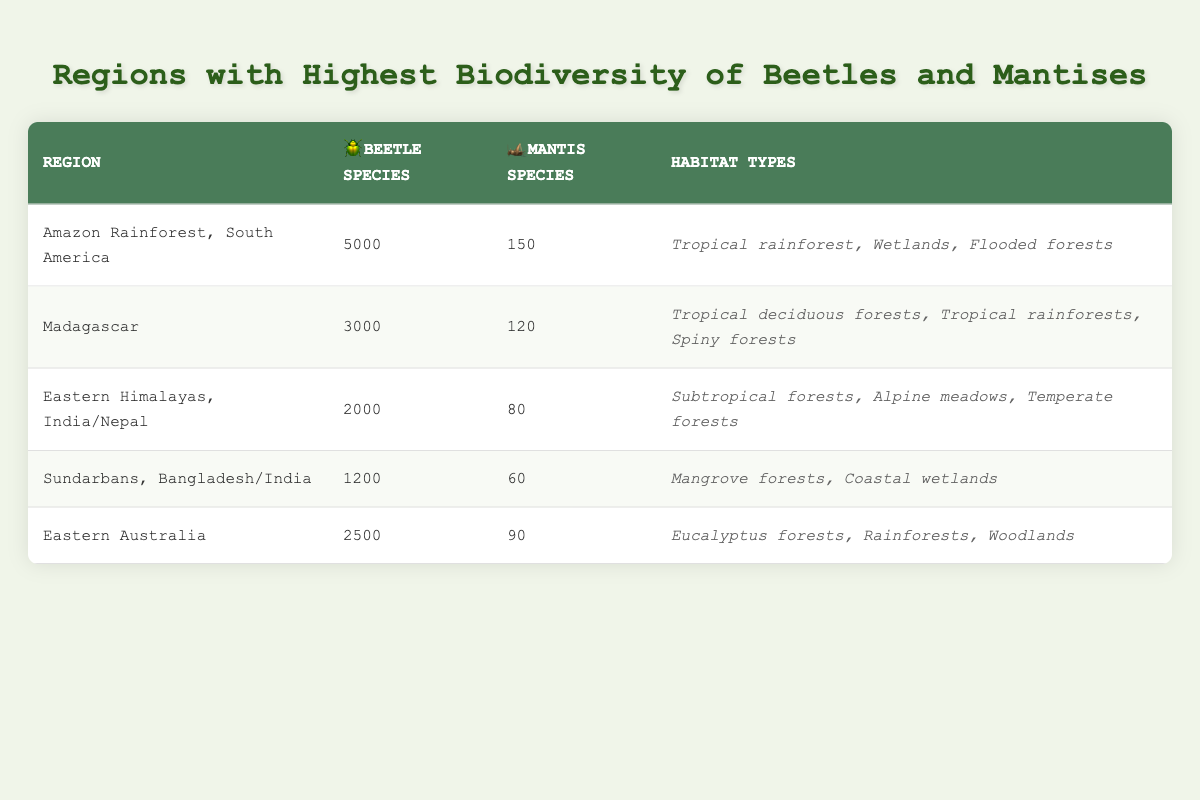What region has the highest count of beetle species? By examining the table, the region with the highest count of beetle species is the Amazon Rainforest, South America, which has 5000 species.
Answer: Amazon Rainforest, South America How many mantis species are found in Madagascar? From the table, Madagascar has 120 species of mantis as indicated in the corresponding column.
Answer: 120 Which region has the lowest number of beetle species? Looking at the beetle species count, Sundarbans has the lowest number with 1200 species.
Answer: Sundarbans, Bangladesh/India What is the total count of mantis species across all regions? To find the total mantis species, sum the counts for each region: 150 + 120 + 80 + 60 + 90 = 500.
Answer: 500 Is there a region with more than 3000 beetle species? Yes, according to the data, the Amazon Rainforest and Madagascar both have more than 3000 beetle species in their respective counts, as Amazon has 5000 and Madagascar has 3000.
Answer: Yes What is the average number of beetle species across all regions? To calculate the average, sum the beetle species counts: 5000 + 3000 + 2000 + 1200 + 2500 = 13700. Divide by the number of regions (5), which gives us 13700 / 5 = 2740.
Answer: 2740 Which habitat type is found in the Amazon Rainforest? The table lists the habitat types for the Amazon Rainforest as "Tropical rainforest, Wetlands, Flooded forests."
Answer: Tropical rainforest, Wetlands, Flooded forests Is Eastern Australia home to more mantis species than Eastern Himalayas? Yes, Eastern Australia has 90 mantis species, while Eastern Himalayas has 80 mantis species, indicating that Eastern Australia has more.
Answer: Yes What is the difference in the number of beetle species between the Amazon Rainforest and Eastern Australia? The count for Amazon Rainforest is 5000 and for Eastern Australia it is 2500. The difference is 5000 - 2500 = 2500 species.
Answer: 2500 